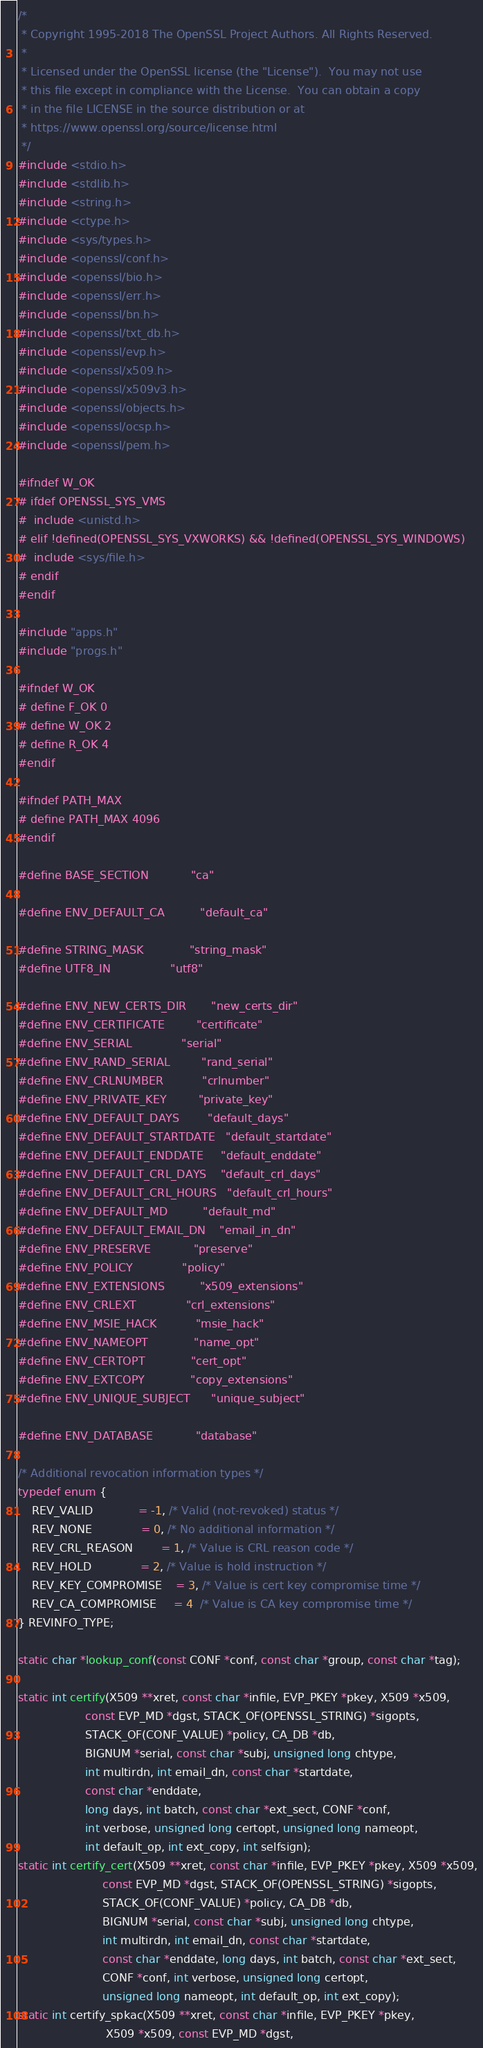Convert code to text. <code><loc_0><loc_0><loc_500><loc_500><_C_>/*
 * Copyright 1995-2018 The OpenSSL Project Authors. All Rights Reserved.
 *
 * Licensed under the OpenSSL license (the "License").  You may not use
 * this file except in compliance with the License.  You can obtain a copy
 * in the file LICENSE in the source distribution or at
 * https://www.openssl.org/source/license.html
 */
#include <stdio.h>
#include <stdlib.h>
#include <string.h>
#include <ctype.h>
#include <sys/types.h>
#include <openssl/conf.h>
#include <openssl/bio.h>
#include <openssl/err.h>
#include <openssl/bn.h>
#include <openssl/txt_db.h>
#include <openssl/evp.h>
#include <openssl/x509.h>
#include <openssl/x509v3.h>
#include <openssl/objects.h>
#include <openssl/ocsp.h>
#include <openssl/pem.h>

#ifndef W_OK
# ifdef OPENSSL_SYS_VMS
#  include <unistd.h>
# elif !defined(OPENSSL_SYS_VXWORKS) && !defined(OPENSSL_SYS_WINDOWS)
#  include <sys/file.h>
# endif
#endif

#include "apps.h"
#include "progs.h"

#ifndef W_OK
# define F_OK 0
# define W_OK 2
# define R_OK 4
#endif

#ifndef PATH_MAX
# define PATH_MAX 4096
#endif

#define BASE_SECTION            "ca"

#define ENV_DEFAULT_CA          "default_ca"

#define STRING_MASK             "string_mask"
#define UTF8_IN                 "utf8"

#define ENV_NEW_CERTS_DIR       "new_certs_dir"
#define ENV_CERTIFICATE         "certificate"
#define ENV_SERIAL              "serial"
#define ENV_RAND_SERIAL         "rand_serial"
#define ENV_CRLNUMBER           "crlnumber"
#define ENV_PRIVATE_KEY         "private_key"
#define ENV_DEFAULT_DAYS        "default_days"
#define ENV_DEFAULT_STARTDATE   "default_startdate"
#define ENV_DEFAULT_ENDDATE     "default_enddate"
#define ENV_DEFAULT_CRL_DAYS    "default_crl_days"
#define ENV_DEFAULT_CRL_HOURS   "default_crl_hours"
#define ENV_DEFAULT_MD          "default_md"
#define ENV_DEFAULT_EMAIL_DN    "email_in_dn"
#define ENV_PRESERVE            "preserve"
#define ENV_POLICY              "policy"
#define ENV_EXTENSIONS          "x509_extensions"
#define ENV_CRLEXT              "crl_extensions"
#define ENV_MSIE_HACK           "msie_hack"
#define ENV_NAMEOPT             "name_opt"
#define ENV_CERTOPT             "cert_opt"
#define ENV_EXTCOPY             "copy_extensions"
#define ENV_UNIQUE_SUBJECT      "unique_subject"

#define ENV_DATABASE            "database"

/* Additional revocation information types */
typedef enum {
    REV_VALID             = -1, /* Valid (not-revoked) status */
    REV_NONE              = 0, /* No additional information */
    REV_CRL_REASON        = 1, /* Value is CRL reason code */
    REV_HOLD              = 2, /* Value is hold instruction */
    REV_KEY_COMPROMISE    = 3, /* Value is cert key compromise time */
    REV_CA_COMPROMISE     = 4  /* Value is CA key compromise time */
} REVINFO_TYPE;

static char *lookup_conf(const CONF *conf, const char *group, const char *tag);

static int certify(X509 **xret, const char *infile, EVP_PKEY *pkey, X509 *x509,
                   const EVP_MD *dgst, STACK_OF(OPENSSL_STRING) *sigopts,
                   STACK_OF(CONF_VALUE) *policy, CA_DB *db,
                   BIGNUM *serial, const char *subj, unsigned long chtype,
                   int multirdn, int email_dn, const char *startdate,
                   const char *enddate,
                   long days, int batch, const char *ext_sect, CONF *conf,
                   int verbose, unsigned long certopt, unsigned long nameopt,
                   int default_op, int ext_copy, int selfsign);
static int certify_cert(X509 **xret, const char *infile, EVP_PKEY *pkey, X509 *x509,
                        const EVP_MD *dgst, STACK_OF(OPENSSL_STRING) *sigopts,
                        STACK_OF(CONF_VALUE) *policy, CA_DB *db,
                        BIGNUM *serial, const char *subj, unsigned long chtype,
                        int multirdn, int email_dn, const char *startdate,
                        const char *enddate, long days, int batch, const char *ext_sect,
                        CONF *conf, int verbose, unsigned long certopt,
                        unsigned long nameopt, int default_op, int ext_copy);
static int certify_spkac(X509 **xret, const char *infile, EVP_PKEY *pkey,
                         X509 *x509, const EVP_MD *dgst,</code> 